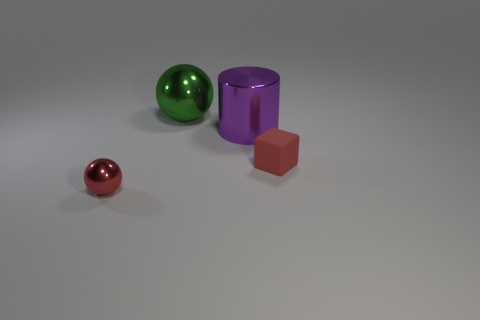What number of objects are either balls in front of the tiny rubber thing or small objects that are right of the red sphere?
Provide a short and direct response. 2. There is a thing that is both in front of the purple metallic cylinder and to the right of the red metal object; what is its color?
Keep it short and to the point. Red. Is the number of large metal cylinders greater than the number of objects?
Give a very brief answer. No. Is the shape of the red object on the left side of the big sphere the same as  the green metallic object?
Offer a terse response. Yes. How many matte things are tiny green cylinders or large purple objects?
Your response must be concise. 0. Are there any red balls made of the same material as the purple thing?
Your answer should be very brief. Yes. What is the large purple object made of?
Offer a terse response. Metal. What shape is the large shiny object that is on the right side of the sphere behind the cube that is to the right of the purple thing?
Ensure brevity in your answer.  Cylinder. Is the number of tiny spheres behind the big green ball greater than the number of metal balls?
Provide a succinct answer. No. Does the big purple object have the same shape as the small thing in front of the rubber block?
Offer a very short reply. No. 